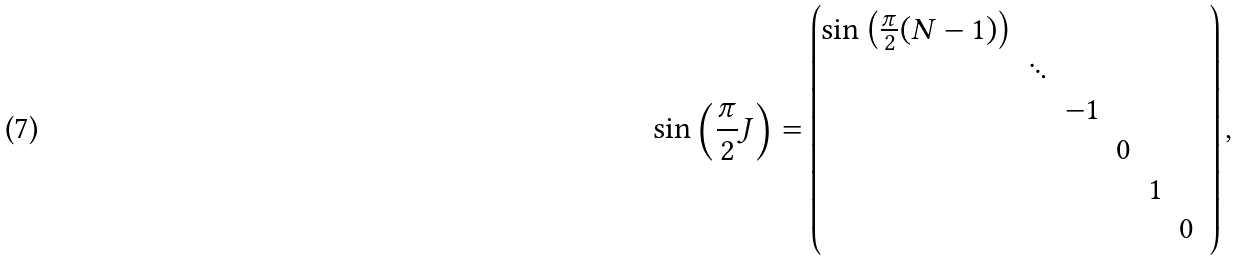<formula> <loc_0><loc_0><loc_500><loc_500>\sin \left ( \frac { \pi } { 2 } J \right ) = \begin{pmatrix} \sin \left ( \frac { \pi } { 2 } ( N - 1 ) \right ) & & & & & & \\ & \ddots & & & & & \\ & & - 1 & \\ & & & 0 & \\ & & & & 1 & \\ & & & & & 0 \\ \end{pmatrix} ,</formula> 